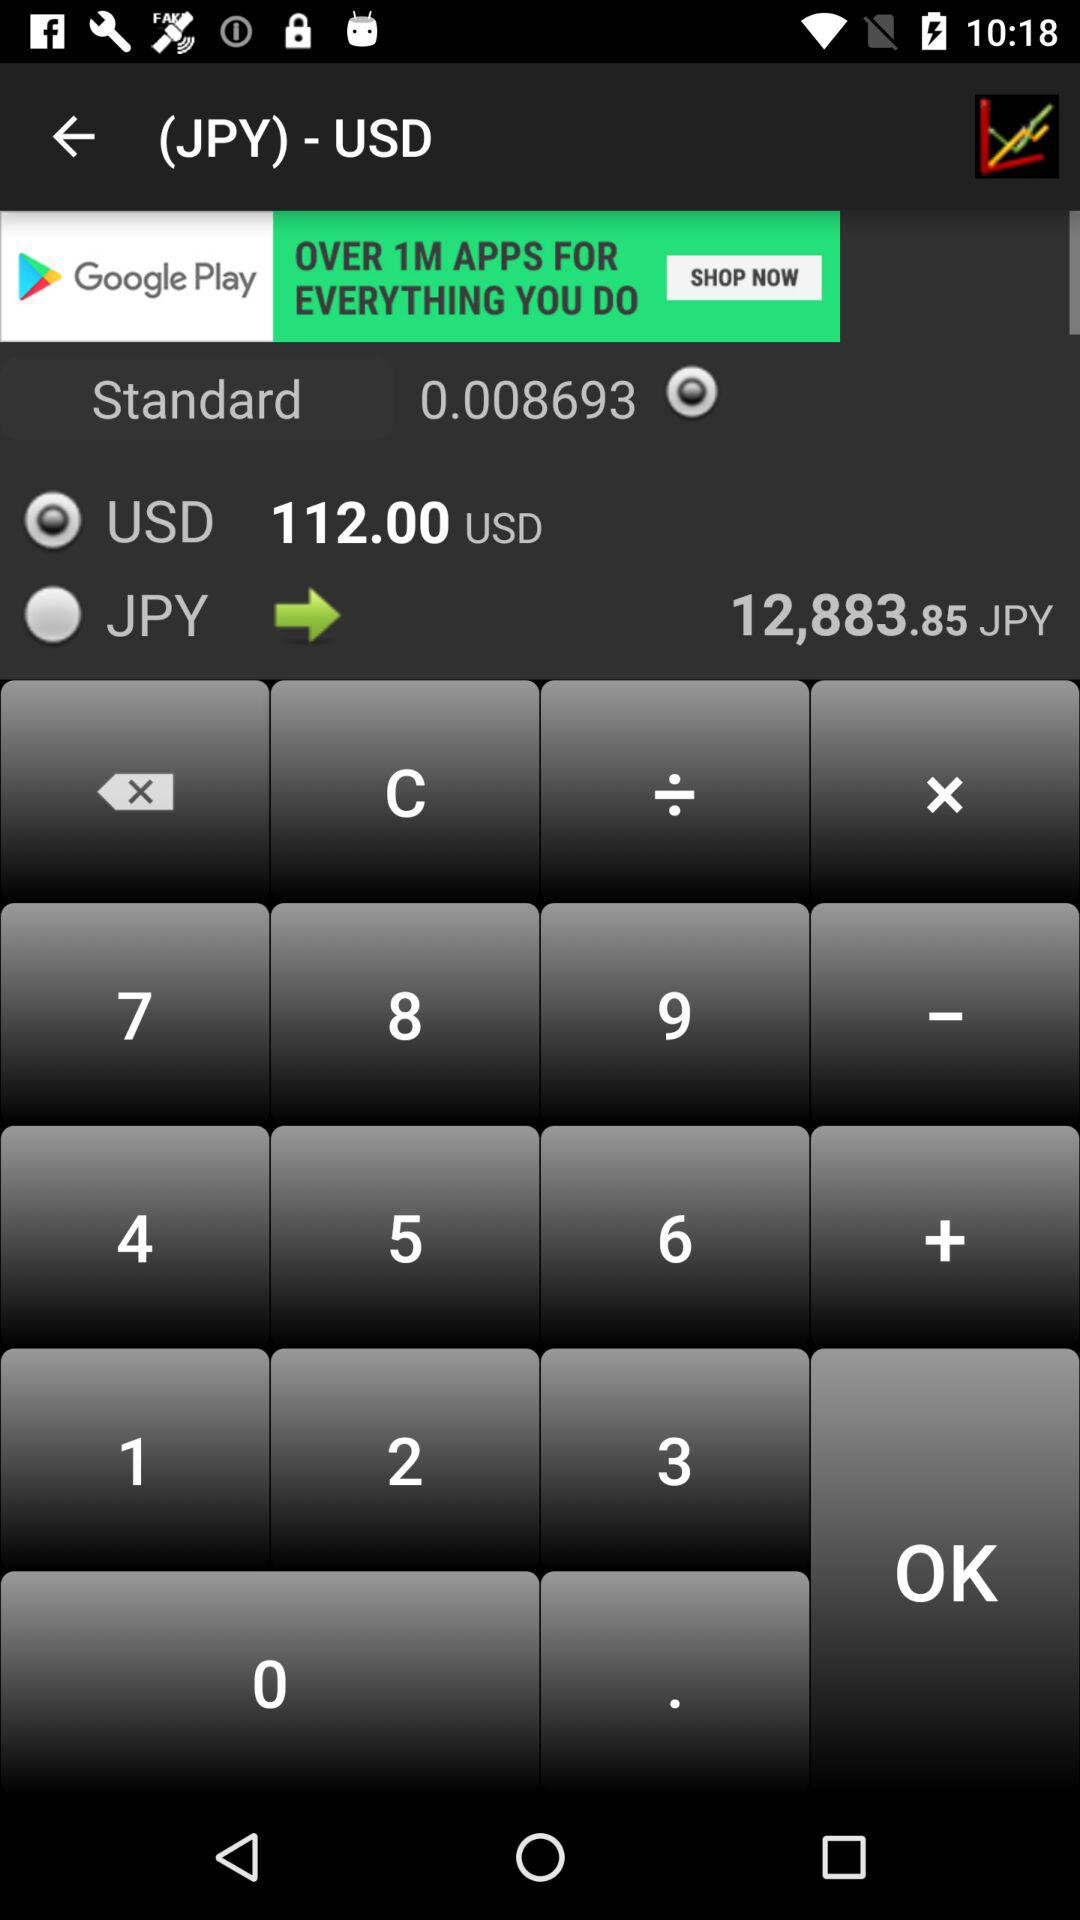What is the value of JPY? The value of the JPY is 12,883.85. 